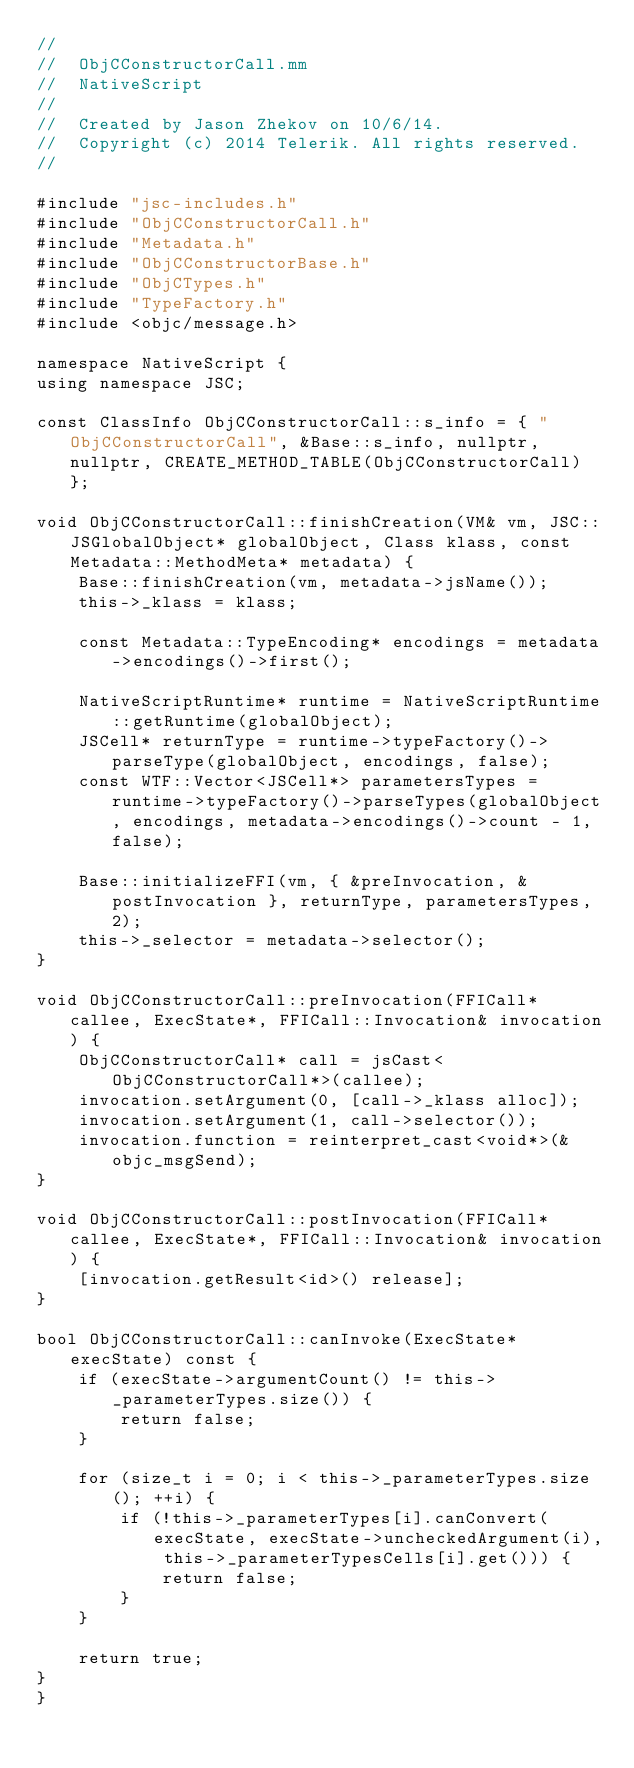Convert code to text. <code><loc_0><loc_0><loc_500><loc_500><_ObjectiveC_>//
//  ObjCConstructorCall.mm
//  NativeScript
//
//  Created by Jason Zhekov on 10/6/14.
//  Copyright (c) 2014 Telerik. All rights reserved.
//

#include "jsc-includes.h"
#include "ObjCConstructorCall.h"
#include "Metadata.h"
#include "ObjCConstructorBase.h"
#include "ObjCTypes.h"
#include "TypeFactory.h"
#include <objc/message.h>

namespace NativeScript {
using namespace JSC;

const ClassInfo ObjCConstructorCall::s_info = { "ObjCConstructorCall", &Base::s_info, nullptr, nullptr, CREATE_METHOD_TABLE(ObjCConstructorCall) };

void ObjCConstructorCall::finishCreation(VM& vm, JSC::JSGlobalObject* globalObject, Class klass, const Metadata::MethodMeta* metadata) {
    Base::finishCreation(vm, metadata->jsName());
    this->_klass = klass;

    const Metadata::TypeEncoding* encodings = metadata->encodings()->first();

    NativeScriptRuntime* runtime = NativeScriptRuntime::getRuntime(globalObject);
    JSCell* returnType = runtime->typeFactory()->parseType(globalObject, encodings, false);
    const WTF::Vector<JSCell*> parametersTypes = runtime->typeFactory()->parseTypes(globalObject, encodings, metadata->encodings()->count - 1, false);

    Base::initializeFFI(vm, { &preInvocation, &postInvocation }, returnType, parametersTypes, 2);
    this->_selector = metadata->selector();
}

void ObjCConstructorCall::preInvocation(FFICall* callee, ExecState*, FFICall::Invocation& invocation) {
    ObjCConstructorCall* call = jsCast<ObjCConstructorCall*>(callee);
    invocation.setArgument(0, [call->_klass alloc]);
    invocation.setArgument(1, call->selector());
    invocation.function = reinterpret_cast<void*>(&objc_msgSend);
}

void ObjCConstructorCall::postInvocation(FFICall* callee, ExecState*, FFICall::Invocation& invocation) {
    [invocation.getResult<id>() release];
}

bool ObjCConstructorCall::canInvoke(ExecState* execState) const {
    if (execState->argumentCount() != this->_parameterTypes.size()) {
        return false;
    }

    for (size_t i = 0; i < this->_parameterTypes.size(); ++i) {
        if (!this->_parameterTypes[i].canConvert(execState, execState->uncheckedArgument(i), this->_parameterTypesCells[i].get())) {
            return false;
        }
    }

    return true;
}
}
</code> 